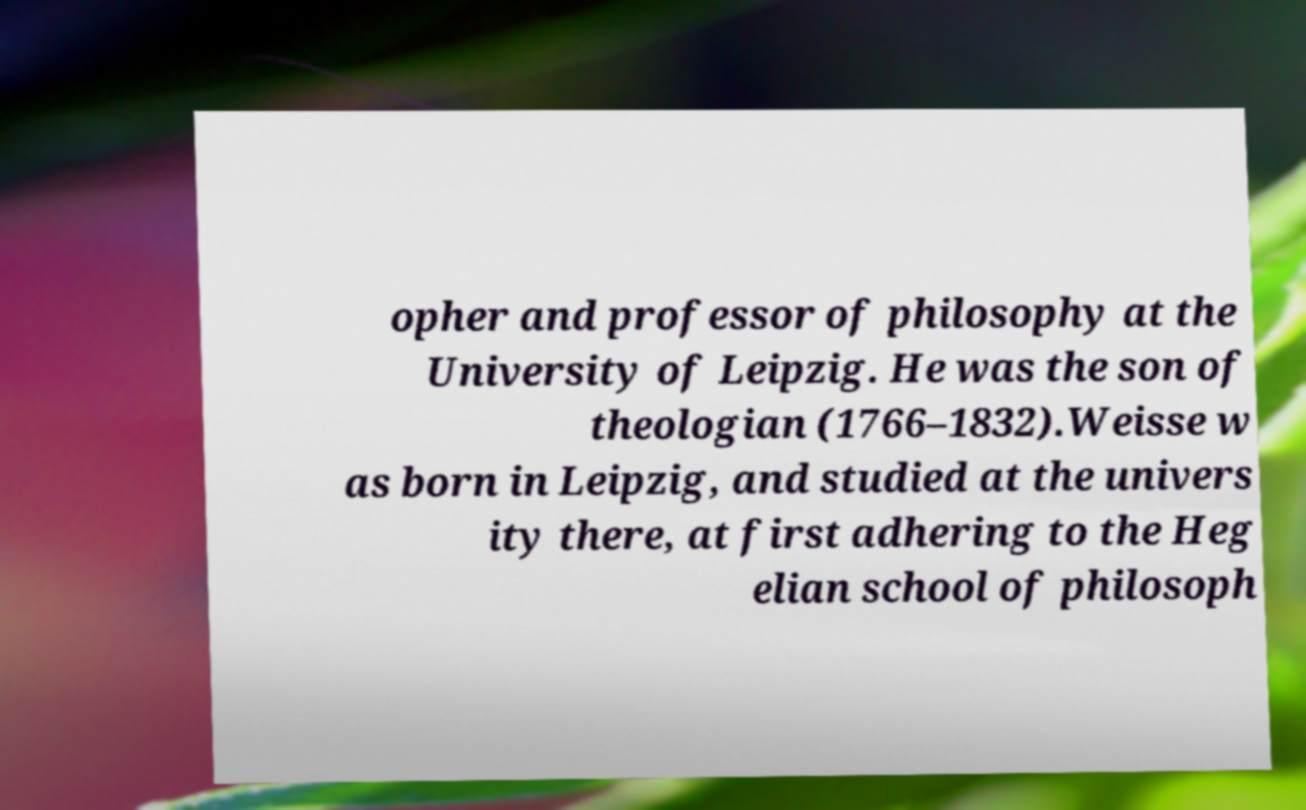What messages or text are displayed in this image? I need them in a readable, typed format. opher and professor of philosophy at the University of Leipzig. He was the son of theologian (1766–1832).Weisse w as born in Leipzig, and studied at the univers ity there, at first adhering to the Heg elian school of philosoph 